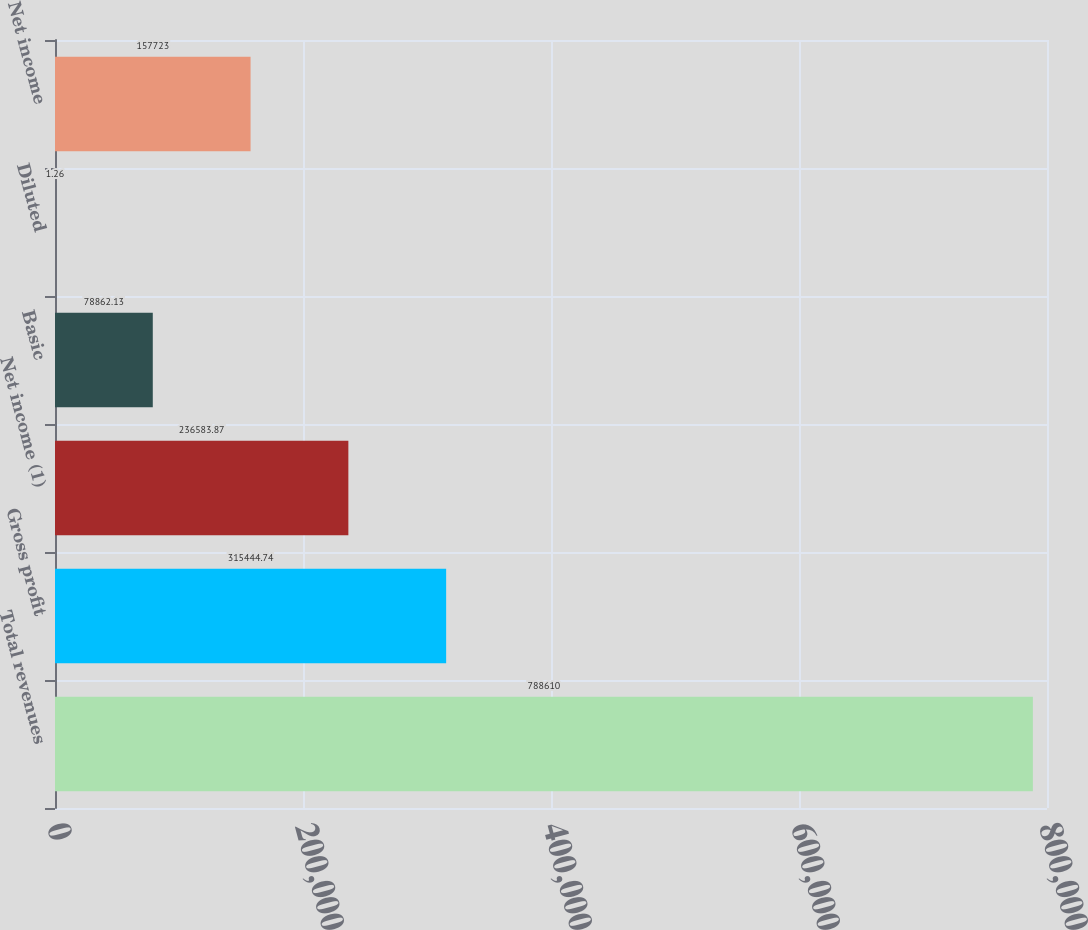<chart> <loc_0><loc_0><loc_500><loc_500><bar_chart><fcel>Total revenues<fcel>Gross profit<fcel>Net income (1)<fcel>Basic<fcel>Diluted<fcel>Net income<nl><fcel>788610<fcel>315445<fcel>236584<fcel>78862.1<fcel>1.26<fcel>157723<nl></chart> 